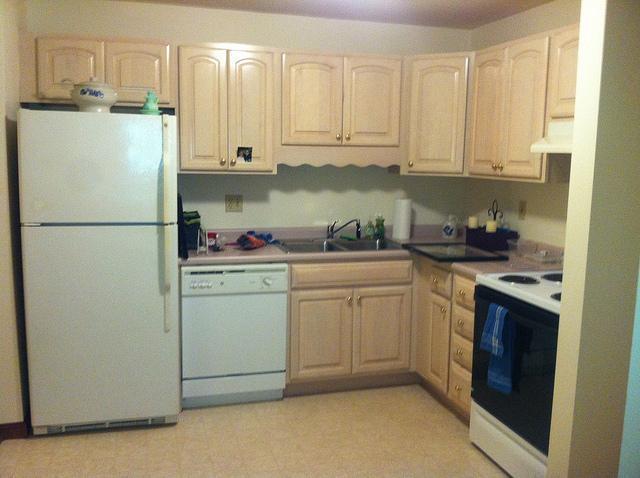How many appliances is there?
Give a very brief answer. 3. How many sinks can be seen?
Give a very brief answer. 1. How many people in the image?
Give a very brief answer. 0. 